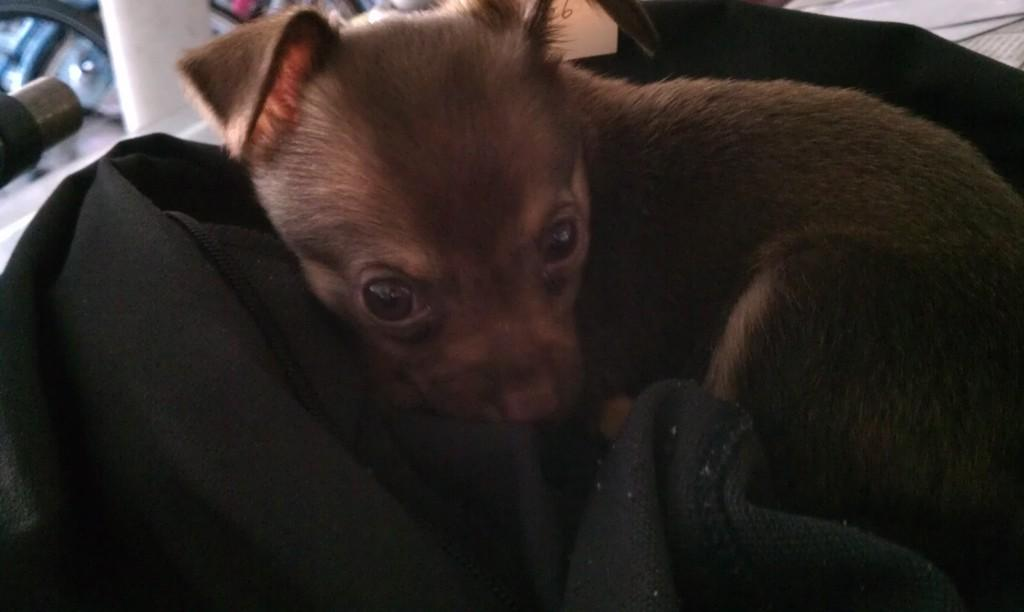What animal is present in the image? There is a dog in the image. What is the dog positioned on? The dog is on a black color cloth. What type of punishment is the dog receiving in the image? There is no indication in the dog is receiving any punishment in the image; it is simply sitting on a black color cloth. 